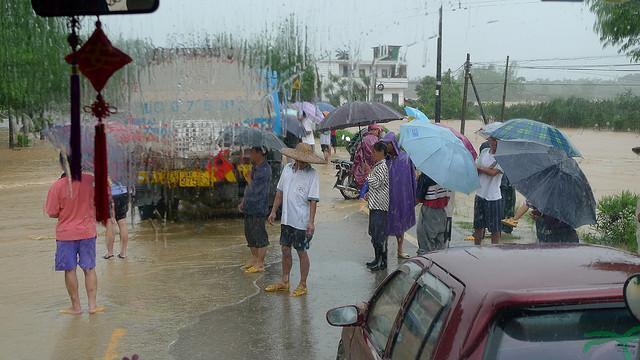How many vehicles are visible?
Give a very brief answer. 1. How many red umbrellas?
Give a very brief answer. 1. How many trucks are in the photo?
Give a very brief answer. 1. How many umbrellas are visible?
Give a very brief answer. 3. How many people are visible?
Give a very brief answer. 7. How many banana stems without bananas are there?
Give a very brief answer. 0. 